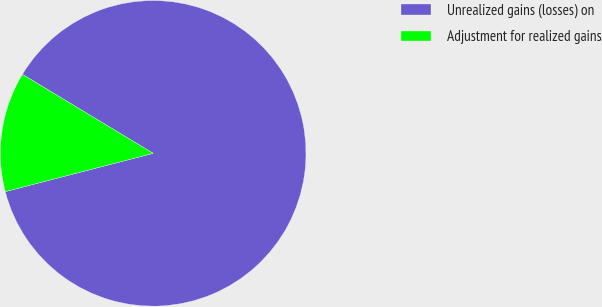Convert chart. <chart><loc_0><loc_0><loc_500><loc_500><pie_chart><fcel>Unrealized gains (losses) on<fcel>Adjustment for realized gains<nl><fcel>87.32%<fcel>12.68%<nl></chart> 